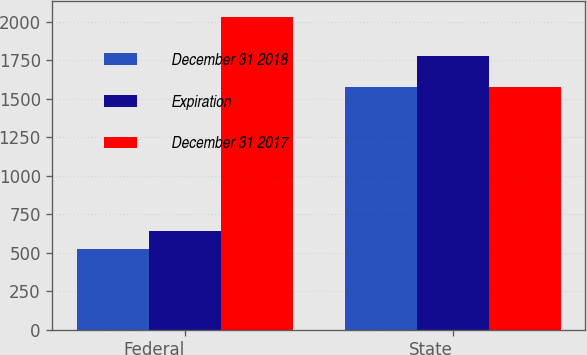<chart> <loc_0><loc_0><loc_500><loc_500><stacked_bar_chart><ecel><fcel>Federal<fcel>State<nl><fcel>December 31 2018<fcel>521<fcel>1577<nl><fcel>Expiration<fcel>640<fcel>1776<nl><fcel>December 31 2017<fcel>2032<fcel>1577<nl></chart> 